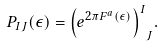<formula> <loc_0><loc_0><loc_500><loc_500>P _ { I J } ( \epsilon ) = { \left ( e ^ { 2 \pi F ^ { a } ( \epsilon ) } \right ) ^ { I } } _ { J } .</formula> 